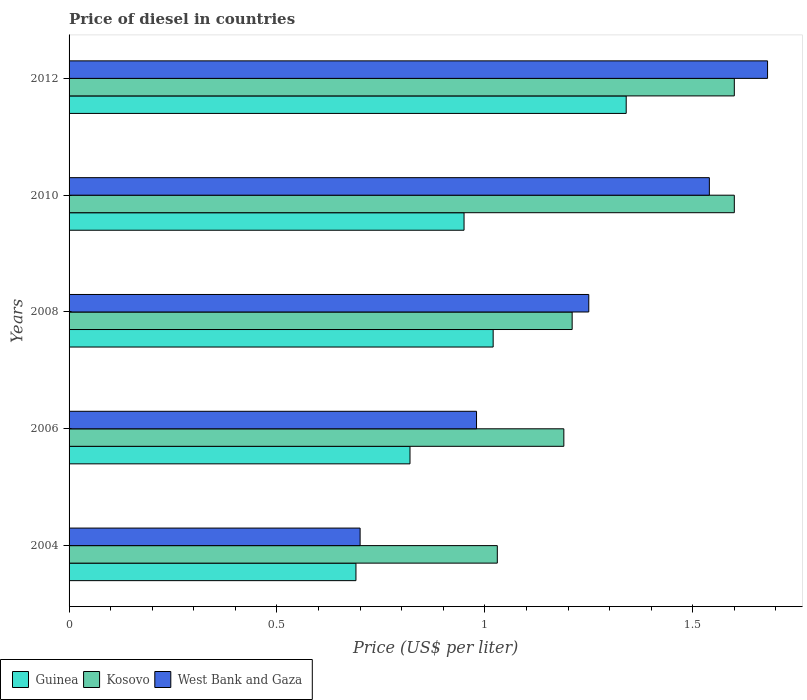Are the number of bars on each tick of the Y-axis equal?
Keep it short and to the point. Yes. How many bars are there on the 5th tick from the top?
Your response must be concise. 3. What is the label of the 3rd group of bars from the top?
Your response must be concise. 2008. What is the price of diesel in Kosovo in 2008?
Your response must be concise. 1.21. Across all years, what is the minimum price of diesel in Guinea?
Keep it short and to the point. 0.69. What is the total price of diesel in West Bank and Gaza in the graph?
Your answer should be very brief. 6.15. What is the difference between the price of diesel in Guinea in 2004 and that in 2010?
Ensure brevity in your answer.  -0.26. What is the difference between the price of diesel in Guinea in 2004 and the price of diesel in Kosovo in 2008?
Give a very brief answer. -0.52. What is the average price of diesel in Kosovo per year?
Provide a short and direct response. 1.33. In the year 2010, what is the difference between the price of diesel in West Bank and Gaza and price of diesel in Kosovo?
Keep it short and to the point. -0.06. In how many years, is the price of diesel in West Bank and Gaza greater than 0.4 US$?
Your response must be concise. 5. What is the ratio of the price of diesel in West Bank and Gaza in 2006 to that in 2012?
Your response must be concise. 0.58. Is the difference between the price of diesel in West Bank and Gaza in 2006 and 2010 greater than the difference between the price of diesel in Kosovo in 2006 and 2010?
Offer a very short reply. No. What is the difference between the highest and the second highest price of diesel in West Bank and Gaza?
Provide a succinct answer. 0.14. What is the difference between the highest and the lowest price of diesel in Kosovo?
Your answer should be very brief. 0.57. Is the sum of the price of diesel in Guinea in 2006 and 2010 greater than the maximum price of diesel in Kosovo across all years?
Your response must be concise. Yes. What does the 2nd bar from the top in 2004 represents?
Provide a succinct answer. Kosovo. What does the 2nd bar from the bottom in 2008 represents?
Offer a terse response. Kosovo. How many bars are there?
Your response must be concise. 15. Are all the bars in the graph horizontal?
Offer a terse response. Yes. How many years are there in the graph?
Provide a succinct answer. 5. Does the graph contain grids?
Offer a very short reply. No. How are the legend labels stacked?
Keep it short and to the point. Horizontal. What is the title of the graph?
Ensure brevity in your answer.  Price of diesel in countries. Does "Georgia" appear as one of the legend labels in the graph?
Your answer should be compact. No. What is the label or title of the X-axis?
Ensure brevity in your answer.  Price (US$ per liter). What is the label or title of the Y-axis?
Give a very brief answer. Years. What is the Price (US$ per liter) of Guinea in 2004?
Your response must be concise. 0.69. What is the Price (US$ per liter) of Kosovo in 2004?
Give a very brief answer. 1.03. What is the Price (US$ per liter) in Guinea in 2006?
Give a very brief answer. 0.82. What is the Price (US$ per liter) of Kosovo in 2006?
Ensure brevity in your answer.  1.19. What is the Price (US$ per liter) of Guinea in 2008?
Make the answer very short. 1.02. What is the Price (US$ per liter) in Kosovo in 2008?
Your answer should be compact. 1.21. What is the Price (US$ per liter) of West Bank and Gaza in 2008?
Your answer should be very brief. 1.25. What is the Price (US$ per liter) in Guinea in 2010?
Make the answer very short. 0.95. What is the Price (US$ per liter) of West Bank and Gaza in 2010?
Your answer should be compact. 1.54. What is the Price (US$ per liter) of Guinea in 2012?
Ensure brevity in your answer.  1.34. What is the Price (US$ per liter) in West Bank and Gaza in 2012?
Your answer should be very brief. 1.68. Across all years, what is the maximum Price (US$ per liter) of Guinea?
Your response must be concise. 1.34. Across all years, what is the maximum Price (US$ per liter) in Kosovo?
Give a very brief answer. 1.6. Across all years, what is the maximum Price (US$ per liter) of West Bank and Gaza?
Keep it short and to the point. 1.68. Across all years, what is the minimum Price (US$ per liter) of Guinea?
Your answer should be compact. 0.69. Across all years, what is the minimum Price (US$ per liter) in Kosovo?
Your answer should be compact. 1.03. Across all years, what is the minimum Price (US$ per liter) of West Bank and Gaza?
Offer a very short reply. 0.7. What is the total Price (US$ per liter) of Guinea in the graph?
Your answer should be compact. 4.82. What is the total Price (US$ per liter) in Kosovo in the graph?
Your response must be concise. 6.63. What is the total Price (US$ per liter) of West Bank and Gaza in the graph?
Offer a terse response. 6.15. What is the difference between the Price (US$ per liter) of Guinea in 2004 and that in 2006?
Give a very brief answer. -0.13. What is the difference between the Price (US$ per liter) in Kosovo in 2004 and that in 2006?
Keep it short and to the point. -0.16. What is the difference between the Price (US$ per liter) in West Bank and Gaza in 2004 and that in 2006?
Your answer should be very brief. -0.28. What is the difference between the Price (US$ per liter) in Guinea in 2004 and that in 2008?
Give a very brief answer. -0.33. What is the difference between the Price (US$ per liter) of Kosovo in 2004 and that in 2008?
Ensure brevity in your answer.  -0.18. What is the difference between the Price (US$ per liter) in West Bank and Gaza in 2004 and that in 2008?
Provide a short and direct response. -0.55. What is the difference between the Price (US$ per liter) of Guinea in 2004 and that in 2010?
Offer a terse response. -0.26. What is the difference between the Price (US$ per liter) of Kosovo in 2004 and that in 2010?
Your answer should be compact. -0.57. What is the difference between the Price (US$ per liter) of West Bank and Gaza in 2004 and that in 2010?
Give a very brief answer. -0.84. What is the difference between the Price (US$ per liter) in Guinea in 2004 and that in 2012?
Offer a very short reply. -0.65. What is the difference between the Price (US$ per liter) in Kosovo in 2004 and that in 2012?
Offer a terse response. -0.57. What is the difference between the Price (US$ per liter) of West Bank and Gaza in 2004 and that in 2012?
Keep it short and to the point. -0.98. What is the difference between the Price (US$ per liter) of Guinea in 2006 and that in 2008?
Your answer should be compact. -0.2. What is the difference between the Price (US$ per liter) of Kosovo in 2006 and that in 2008?
Your answer should be very brief. -0.02. What is the difference between the Price (US$ per liter) of West Bank and Gaza in 2006 and that in 2008?
Provide a succinct answer. -0.27. What is the difference between the Price (US$ per liter) of Guinea in 2006 and that in 2010?
Your answer should be compact. -0.13. What is the difference between the Price (US$ per liter) in Kosovo in 2006 and that in 2010?
Provide a short and direct response. -0.41. What is the difference between the Price (US$ per liter) of West Bank and Gaza in 2006 and that in 2010?
Offer a very short reply. -0.56. What is the difference between the Price (US$ per liter) of Guinea in 2006 and that in 2012?
Provide a succinct answer. -0.52. What is the difference between the Price (US$ per liter) of Kosovo in 2006 and that in 2012?
Offer a terse response. -0.41. What is the difference between the Price (US$ per liter) of West Bank and Gaza in 2006 and that in 2012?
Keep it short and to the point. -0.7. What is the difference between the Price (US$ per liter) in Guinea in 2008 and that in 2010?
Make the answer very short. 0.07. What is the difference between the Price (US$ per liter) in Kosovo in 2008 and that in 2010?
Offer a very short reply. -0.39. What is the difference between the Price (US$ per liter) in West Bank and Gaza in 2008 and that in 2010?
Your answer should be compact. -0.29. What is the difference between the Price (US$ per liter) of Guinea in 2008 and that in 2012?
Keep it short and to the point. -0.32. What is the difference between the Price (US$ per liter) of Kosovo in 2008 and that in 2012?
Your answer should be very brief. -0.39. What is the difference between the Price (US$ per liter) of West Bank and Gaza in 2008 and that in 2012?
Offer a very short reply. -0.43. What is the difference between the Price (US$ per liter) in Guinea in 2010 and that in 2012?
Ensure brevity in your answer.  -0.39. What is the difference between the Price (US$ per liter) in Kosovo in 2010 and that in 2012?
Make the answer very short. 0. What is the difference between the Price (US$ per liter) in West Bank and Gaza in 2010 and that in 2012?
Your answer should be very brief. -0.14. What is the difference between the Price (US$ per liter) in Guinea in 2004 and the Price (US$ per liter) in Kosovo in 2006?
Your answer should be compact. -0.5. What is the difference between the Price (US$ per liter) of Guinea in 2004 and the Price (US$ per liter) of West Bank and Gaza in 2006?
Keep it short and to the point. -0.29. What is the difference between the Price (US$ per liter) of Guinea in 2004 and the Price (US$ per liter) of Kosovo in 2008?
Keep it short and to the point. -0.52. What is the difference between the Price (US$ per liter) in Guinea in 2004 and the Price (US$ per liter) in West Bank and Gaza in 2008?
Keep it short and to the point. -0.56. What is the difference between the Price (US$ per liter) of Kosovo in 2004 and the Price (US$ per liter) of West Bank and Gaza in 2008?
Provide a succinct answer. -0.22. What is the difference between the Price (US$ per liter) of Guinea in 2004 and the Price (US$ per liter) of Kosovo in 2010?
Your answer should be very brief. -0.91. What is the difference between the Price (US$ per liter) in Guinea in 2004 and the Price (US$ per liter) in West Bank and Gaza in 2010?
Offer a terse response. -0.85. What is the difference between the Price (US$ per liter) of Kosovo in 2004 and the Price (US$ per liter) of West Bank and Gaza in 2010?
Ensure brevity in your answer.  -0.51. What is the difference between the Price (US$ per liter) in Guinea in 2004 and the Price (US$ per liter) in Kosovo in 2012?
Keep it short and to the point. -0.91. What is the difference between the Price (US$ per liter) of Guinea in 2004 and the Price (US$ per liter) of West Bank and Gaza in 2012?
Make the answer very short. -0.99. What is the difference between the Price (US$ per liter) in Kosovo in 2004 and the Price (US$ per liter) in West Bank and Gaza in 2012?
Offer a very short reply. -0.65. What is the difference between the Price (US$ per liter) in Guinea in 2006 and the Price (US$ per liter) in Kosovo in 2008?
Offer a very short reply. -0.39. What is the difference between the Price (US$ per liter) in Guinea in 2006 and the Price (US$ per liter) in West Bank and Gaza in 2008?
Ensure brevity in your answer.  -0.43. What is the difference between the Price (US$ per liter) of Kosovo in 2006 and the Price (US$ per liter) of West Bank and Gaza in 2008?
Offer a terse response. -0.06. What is the difference between the Price (US$ per liter) in Guinea in 2006 and the Price (US$ per liter) in Kosovo in 2010?
Provide a short and direct response. -0.78. What is the difference between the Price (US$ per liter) of Guinea in 2006 and the Price (US$ per liter) of West Bank and Gaza in 2010?
Provide a short and direct response. -0.72. What is the difference between the Price (US$ per liter) in Kosovo in 2006 and the Price (US$ per liter) in West Bank and Gaza in 2010?
Ensure brevity in your answer.  -0.35. What is the difference between the Price (US$ per liter) in Guinea in 2006 and the Price (US$ per liter) in Kosovo in 2012?
Ensure brevity in your answer.  -0.78. What is the difference between the Price (US$ per liter) of Guinea in 2006 and the Price (US$ per liter) of West Bank and Gaza in 2012?
Provide a short and direct response. -0.86. What is the difference between the Price (US$ per liter) in Kosovo in 2006 and the Price (US$ per liter) in West Bank and Gaza in 2012?
Your response must be concise. -0.49. What is the difference between the Price (US$ per liter) in Guinea in 2008 and the Price (US$ per liter) in Kosovo in 2010?
Your response must be concise. -0.58. What is the difference between the Price (US$ per liter) of Guinea in 2008 and the Price (US$ per liter) of West Bank and Gaza in 2010?
Offer a very short reply. -0.52. What is the difference between the Price (US$ per liter) of Kosovo in 2008 and the Price (US$ per liter) of West Bank and Gaza in 2010?
Provide a short and direct response. -0.33. What is the difference between the Price (US$ per liter) of Guinea in 2008 and the Price (US$ per liter) of Kosovo in 2012?
Provide a short and direct response. -0.58. What is the difference between the Price (US$ per liter) of Guinea in 2008 and the Price (US$ per liter) of West Bank and Gaza in 2012?
Provide a succinct answer. -0.66. What is the difference between the Price (US$ per liter) of Kosovo in 2008 and the Price (US$ per liter) of West Bank and Gaza in 2012?
Provide a short and direct response. -0.47. What is the difference between the Price (US$ per liter) of Guinea in 2010 and the Price (US$ per liter) of Kosovo in 2012?
Your answer should be compact. -0.65. What is the difference between the Price (US$ per liter) in Guinea in 2010 and the Price (US$ per liter) in West Bank and Gaza in 2012?
Keep it short and to the point. -0.73. What is the difference between the Price (US$ per liter) in Kosovo in 2010 and the Price (US$ per liter) in West Bank and Gaza in 2012?
Offer a terse response. -0.08. What is the average Price (US$ per liter) of Kosovo per year?
Your response must be concise. 1.33. What is the average Price (US$ per liter) in West Bank and Gaza per year?
Your response must be concise. 1.23. In the year 2004, what is the difference between the Price (US$ per liter) in Guinea and Price (US$ per liter) in Kosovo?
Provide a succinct answer. -0.34. In the year 2004, what is the difference between the Price (US$ per liter) in Guinea and Price (US$ per liter) in West Bank and Gaza?
Offer a terse response. -0.01. In the year 2004, what is the difference between the Price (US$ per liter) of Kosovo and Price (US$ per liter) of West Bank and Gaza?
Make the answer very short. 0.33. In the year 2006, what is the difference between the Price (US$ per liter) in Guinea and Price (US$ per liter) in Kosovo?
Provide a short and direct response. -0.37. In the year 2006, what is the difference between the Price (US$ per liter) of Guinea and Price (US$ per liter) of West Bank and Gaza?
Ensure brevity in your answer.  -0.16. In the year 2006, what is the difference between the Price (US$ per liter) in Kosovo and Price (US$ per liter) in West Bank and Gaza?
Provide a short and direct response. 0.21. In the year 2008, what is the difference between the Price (US$ per liter) in Guinea and Price (US$ per liter) in Kosovo?
Ensure brevity in your answer.  -0.19. In the year 2008, what is the difference between the Price (US$ per liter) of Guinea and Price (US$ per liter) of West Bank and Gaza?
Offer a terse response. -0.23. In the year 2008, what is the difference between the Price (US$ per liter) in Kosovo and Price (US$ per liter) in West Bank and Gaza?
Offer a terse response. -0.04. In the year 2010, what is the difference between the Price (US$ per liter) of Guinea and Price (US$ per liter) of Kosovo?
Keep it short and to the point. -0.65. In the year 2010, what is the difference between the Price (US$ per liter) in Guinea and Price (US$ per liter) in West Bank and Gaza?
Ensure brevity in your answer.  -0.59. In the year 2012, what is the difference between the Price (US$ per liter) in Guinea and Price (US$ per liter) in Kosovo?
Your answer should be compact. -0.26. In the year 2012, what is the difference between the Price (US$ per liter) of Guinea and Price (US$ per liter) of West Bank and Gaza?
Provide a succinct answer. -0.34. In the year 2012, what is the difference between the Price (US$ per liter) in Kosovo and Price (US$ per liter) in West Bank and Gaza?
Keep it short and to the point. -0.08. What is the ratio of the Price (US$ per liter) in Guinea in 2004 to that in 2006?
Ensure brevity in your answer.  0.84. What is the ratio of the Price (US$ per liter) of Kosovo in 2004 to that in 2006?
Your response must be concise. 0.87. What is the ratio of the Price (US$ per liter) of Guinea in 2004 to that in 2008?
Your answer should be compact. 0.68. What is the ratio of the Price (US$ per liter) of Kosovo in 2004 to that in 2008?
Your answer should be very brief. 0.85. What is the ratio of the Price (US$ per liter) of West Bank and Gaza in 2004 to that in 2008?
Make the answer very short. 0.56. What is the ratio of the Price (US$ per liter) in Guinea in 2004 to that in 2010?
Ensure brevity in your answer.  0.73. What is the ratio of the Price (US$ per liter) of Kosovo in 2004 to that in 2010?
Keep it short and to the point. 0.64. What is the ratio of the Price (US$ per liter) of West Bank and Gaza in 2004 to that in 2010?
Offer a terse response. 0.45. What is the ratio of the Price (US$ per liter) of Guinea in 2004 to that in 2012?
Make the answer very short. 0.51. What is the ratio of the Price (US$ per liter) of Kosovo in 2004 to that in 2012?
Keep it short and to the point. 0.64. What is the ratio of the Price (US$ per liter) of West Bank and Gaza in 2004 to that in 2012?
Offer a very short reply. 0.42. What is the ratio of the Price (US$ per liter) of Guinea in 2006 to that in 2008?
Provide a succinct answer. 0.8. What is the ratio of the Price (US$ per liter) in Kosovo in 2006 to that in 2008?
Offer a terse response. 0.98. What is the ratio of the Price (US$ per liter) in West Bank and Gaza in 2006 to that in 2008?
Ensure brevity in your answer.  0.78. What is the ratio of the Price (US$ per liter) of Guinea in 2006 to that in 2010?
Provide a succinct answer. 0.86. What is the ratio of the Price (US$ per liter) in Kosovo in 2006 to that in 2010?
Your answer should be very brief. 0.74. What is the ratio of the Price (US$ per liter) in West Bank and Gaza in 2006 to that in 2010?
Give a very brief answer. 0.64. What is the ratio of the Price (US$ per liter) of Guinea in 2006 to that in 2012?
Provide a succinct answer. 0.61. What is the ratio of the Price (US$ per liter) of Kosovo in 2006 to that in 2012?
Your answer should be compact. 0.74. What is the ratio of the Price (US$ per liter) of West Bank and Gaza in 2006 to that in 2012?
Ensure brevity in your answer.  0.58. What is the ratio of the Price (US$ per liter) in Guinea in 2008 to that in 2010?
Give a very brief answer. 1.07. What is the ratio of the Price (US$ per liter) of Kosovo in 2008 to that in 2010?
Make the answer very short. 0.76. What is the ratio of the Price (US$ per liter) in West Bank and Gaza in 2008 to that in 2010?
Give a very brief answer. 0.81. What is the ratio of the Price (US$ per liter) in Guinea in 2008 to that in 2012?
Provide a succinct answer. 0.76. What is the ratio of the Price (US$ per liter) in Kosovo in 2008 to that in 2012?
Offer a very short reply. 0.76. What is the ratio of the Price (US$ per liter) in West Bank and Gaza in 2008 to that in 2012?
Keep it short and to the point. 0.74. What is the ratio of the Price (US$ per liter) in Guinea in 2010 to that in 2012?
Ensure brevity in your answer.  0.71. What is the ratio of the Price (US$ per liter) in Kosovo in 2010 to that in 2012?
Provide a succinct answer. 1. What is the difference between the highest and the second highest Price (US$ per liter) of Guinea?
Provide a succinct answer. 0.32. What is the difference between the highest and the second highest Price (US$ per liter) in West Bank and Gaza?
Offer a terse response. 0.14. What is the difference between the highest and the lowest Price (US$ per liter) of Guinea?
Offer a very short reply. 0.65. What is the difference between the highest and the lowest Price (US$ per liter) in Kosovo?
Offer a terse response. 0.57. What is the difference between the highest and the lowest Price (US$ per liter) of West Bank and Gaza?
Your response must be concise. 0.98. 